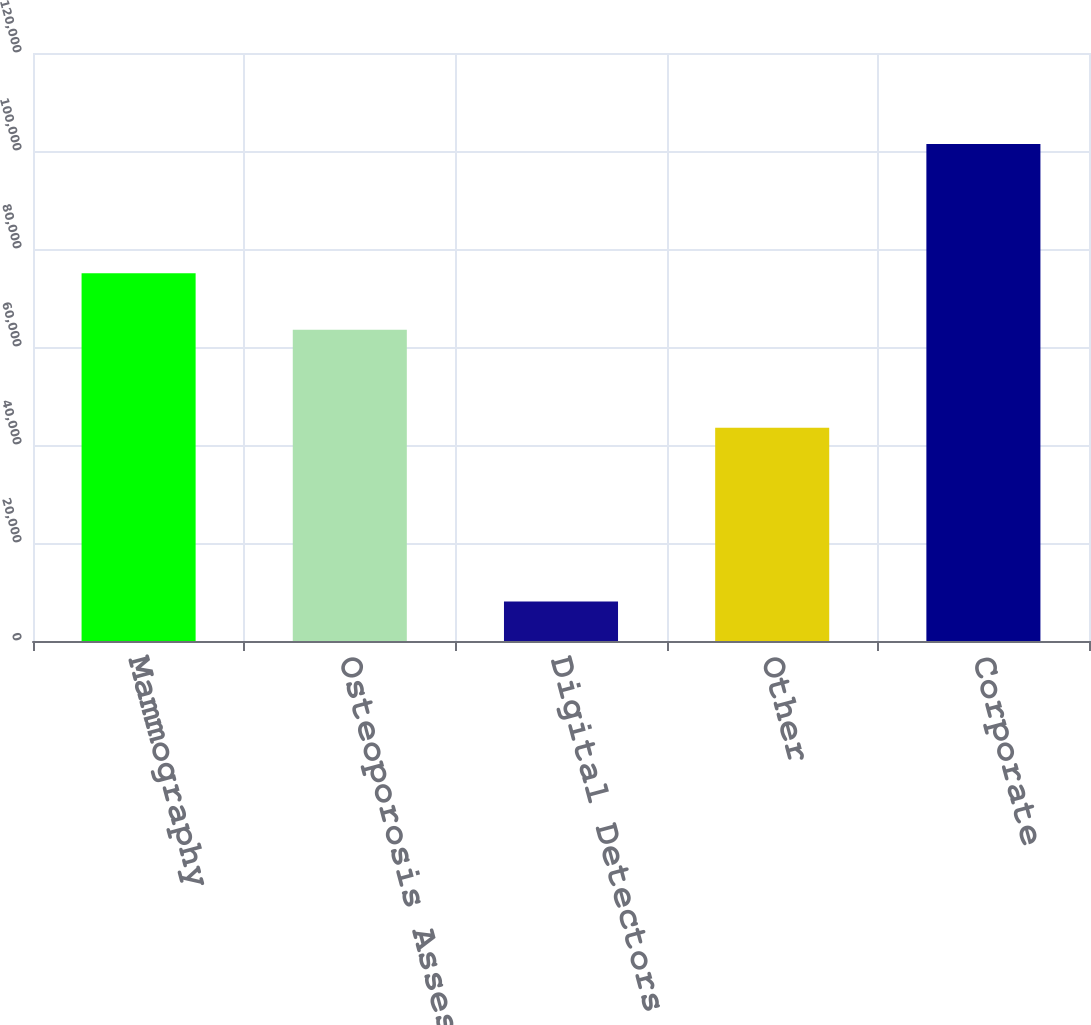Convert chart to OTSL. <chart><loc_0><loc_0><loc_500><loc_500><bar_chart><fcel>Mammography<fcel>Osteoporosis Assessment<fcel>Digital Detectors<fcel>Other<fcel>Corporate<nl><fcel>75039<fcel>63544<fcel>8082<fcel>43527<fcel>101449<nl></chart> 